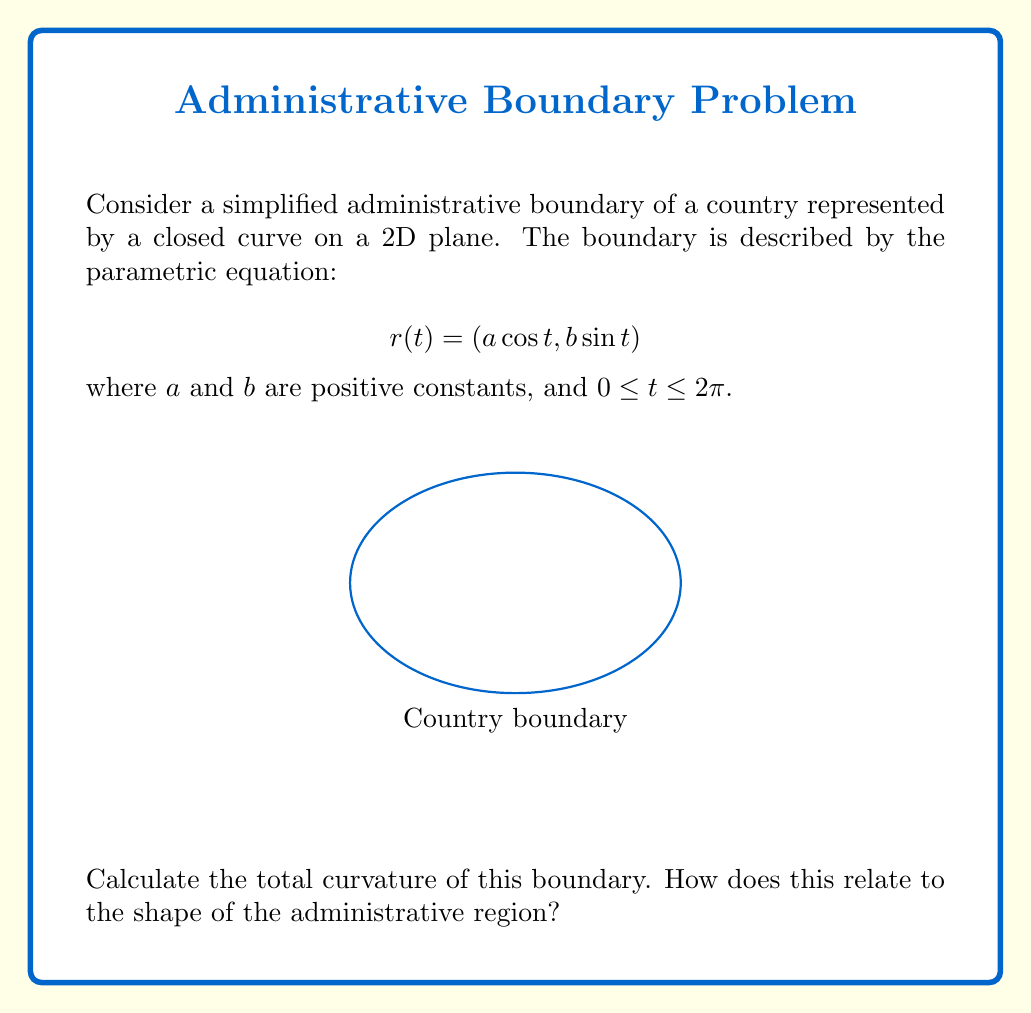Provide a solution to this math problem. To solve this problem, we'll follow these steps:

1) The curvature $\kappa$ of a parametric curve $r(t) = (x(t), y(t))$ is given by:

   $$\kappa = \frac{|x'y'' - y'x''|}{(x'^2 + y'^2)^{3/2}}$$

2) For our curve, we have:
   $x(t) = a \cos t$, $y(t) = b \sin t$
   $x'(t) = -a \sin t$, $y'(t) = b \cos t$
   $x''(t) = -a \cos t$, $y''(t) = -b \sin t$

3) Substituting these into the curvature formula:

   $$\kappa = \frac{|-a\sin t(-b\sin t) - b\cos t(-a\cos t)|}{(a^2\sin^2 t + b^2\cos^2 t)^{3/2}}$$

4) Simplifying:

   $$\kappa = \frac{ab}{(a^2\sin^2 t + b^2\cos^2 t)^{3/2}}$$

5) The total curvature is the integral of the absolute curvature over the entire curve:

   $$\text{Total Curvature} = \int_0^{2\pi} |\kappa| dt = \int_0^{2\pi} \frac{ab}{(a^2\sin^2 t + b^2\cos^2 t)^{3/2}} dt$$

6) This integral evaluates to $2\pi$, regardless of the values of $a$ and $b$.

7) The total curvature of $2\pi$ is a fundamental result in differential geometry. It's known as the Gauss-Bonnet theorem for simple closed curves in the plane.

8) This result indicates that the administrative boundary, despite its elliptical shape, has the same total curvature as a circle. In the context of administrative divisions, this suggests that the overall "turniness" of the boundary is constant, regardless of whether it's more circular ($a=b$) or more elongated ($a\neq b$).
Answer: $2\pi$ 